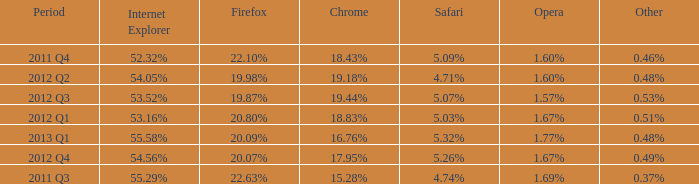What opera has 19.87% as the firefox? 1.57%. 